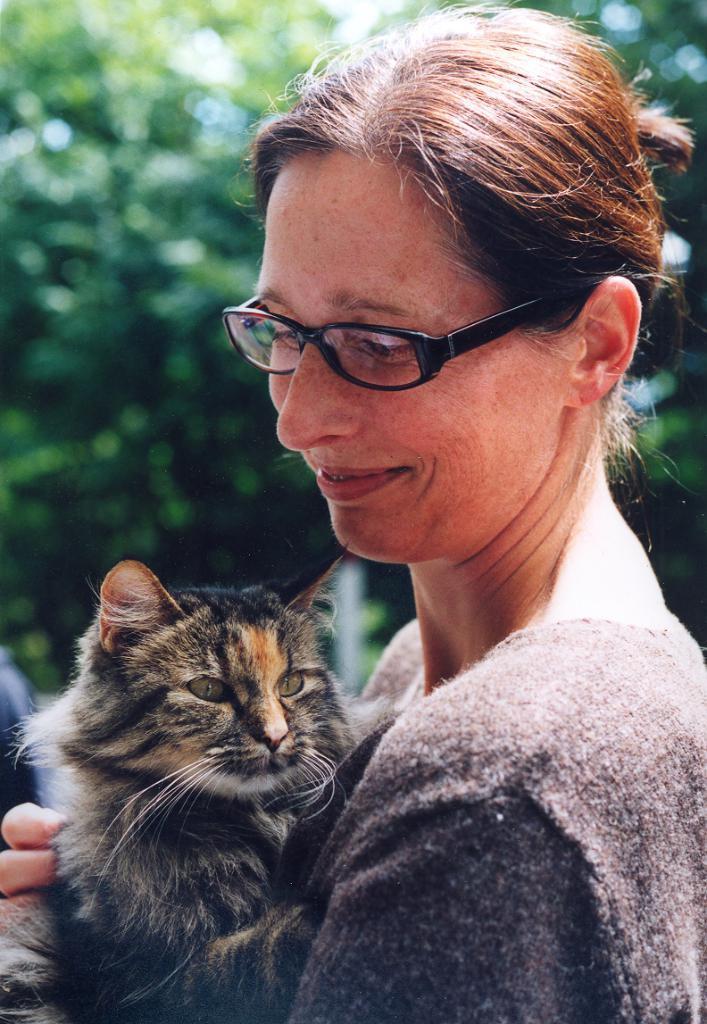Could you give a brief overview of what you see in this image? In this picture a woman is smiling and holding a cat. In the background there are trees. 